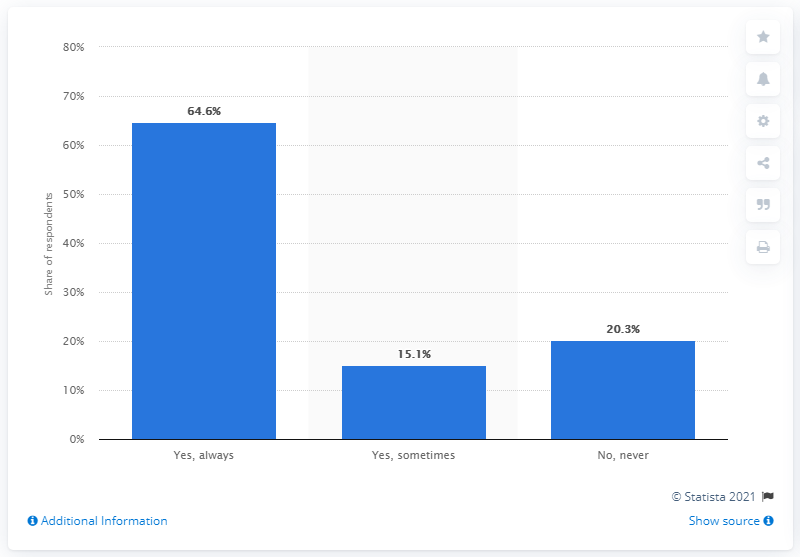Draw attention to some important aspects in this diagram. According to a survey of Italian young adults, 20.3% affirmed that love and sex can be separated. In a survey of Italian young adults, 64.6% stated that love and sex can be separated. 